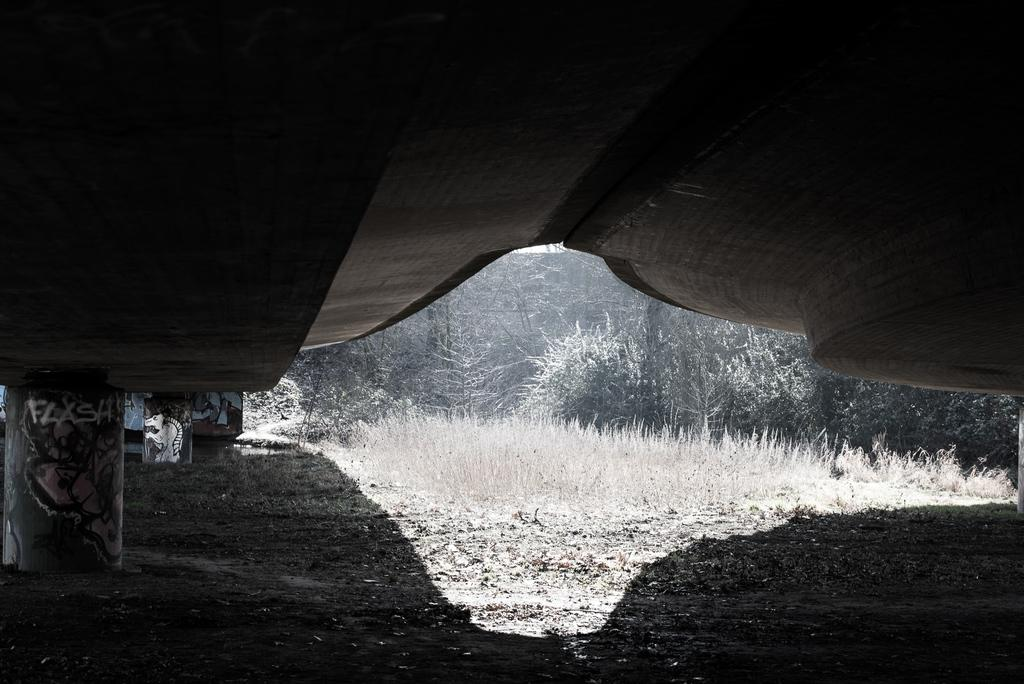What structure is the main subject of the image? There is a bridge in the image. Can you describe the bridge's features? The bridge has pillars on the left side. What can be seen in the background of the image? There are trees and plants in the background of the image. What type of disease is affecting the bridge in the image? There is no indication of any disease affecting the bridge in the image. 